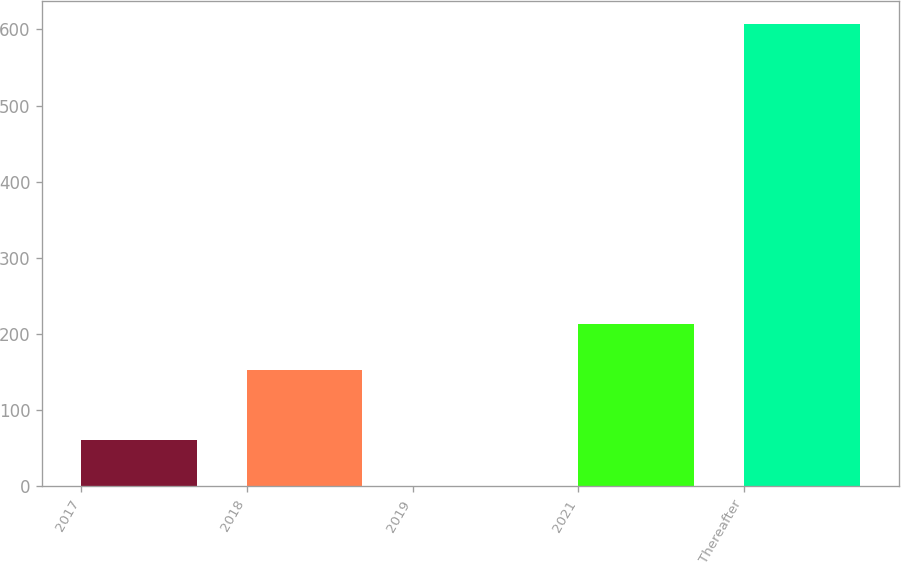<chart> <loc_0><loc_0><loc_500><loc_500><bar_chart><fcel>2017<fcel>2018<fcel>2019<fcel>2021<fcel>Thereafter<nl><fcel>61.36<fcel>153<fcel>0.7<fcel>213.66<fcel>607.3<nl></chart> 